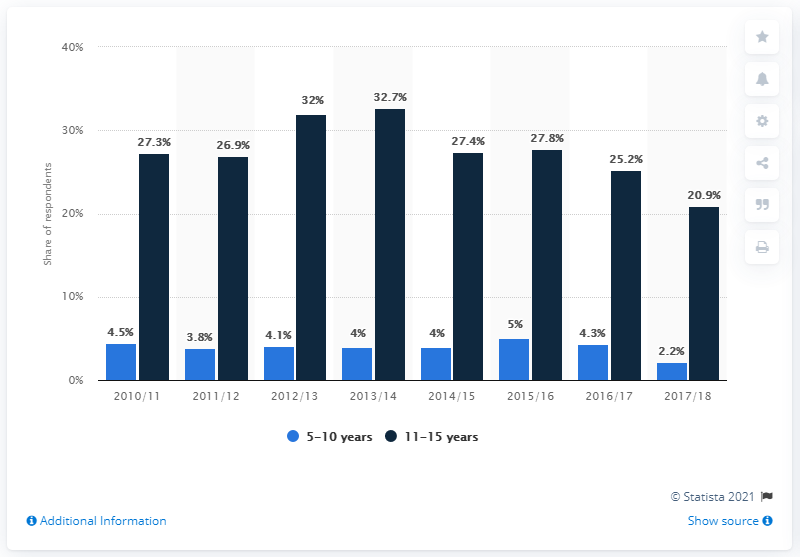Draw attention to some important aspects in this diagram. In the 2017/2018 season, the basketball participation rate was 20.9%. 